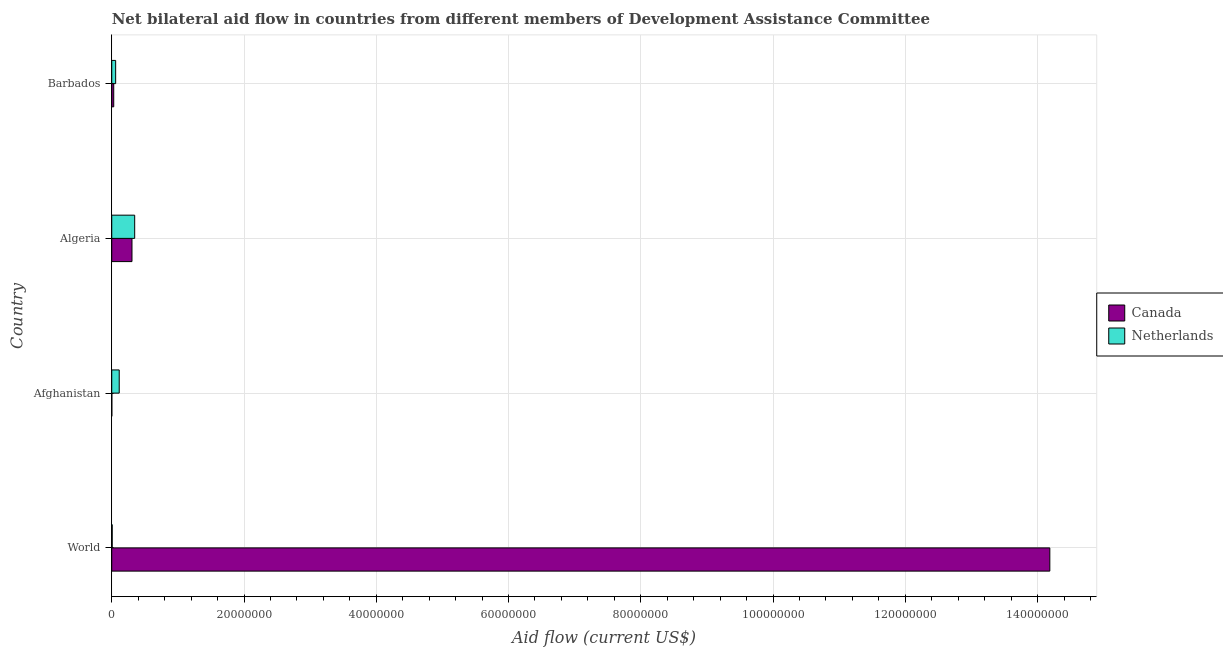How many different coloured bars are there?
Give a very brief answer. 2. Are the number of bars on each tick of the Y-axis equal?
Your answer should be very brief. Yes. How many bars are there on the 4th tick from the bottom?
Provide a short and direct response. 2. What is the label of the 1st group of bars from the top?
Keep it short and to the point. Barbados. What is the amount of aid given by netherlands in Afghanistan?
Your answer should be very brief. 1.13e+06. Across all countries, what is the maximum amount of aid given by canada?
Make the answer very short. 1.42e+08. Across all countries, what is the minimum amount of aid given by canada?
Your response must be concise. 10000. In which country was the amount of aid given by netherlands minimum?
Give a very brief answer. World. What is the total amount of aid given by netherlands in the graph?
Keep it short and to the point. 5.26e+06. What is the difference between the amount of aid given by netherlands in Afghanistan and that in World?
Make the answer very short. 1.06e+06. What is the difference between the amount of aid given by canada in Barbados and the amount of aid given by netherlands in Algeria?
Offer a terse response. -3.17e+06. What is the average amount of aid given by netherlands per country?
Ensure brevity in your answer.  1.32e+06. What is the difference between the amount of aid given by canada and amount of aid given by netherlands in Barbados?
Your answer should be very brief. -2.90e+05. In how many countries, is the amount of aid given by canada greater than 128000000 US$?
Ensure brevity in your answer.  1. What is the ratio of the amount of aid given by netherlands in Barbados to that in World?
Offer a terse response. 8.43. What is the difference between the highest and the second highest amount of aid given by netherlands?
Ensure brevity in your answer.  2.34e+06. What is the difference between the highest and the lowest amount of aid given by canada?
Offer a terse response. 1.42e+08. In how many countries, is the amount of aid given by netherlands greater than the average amount of aid given by netherlands taken over all countries?
Provide a succinct answer. 1. What does the 2nd bar from the top in Afghanistan represents?
Make the answer very short. Canada. How many bars are there?
Keep it short and to the point. 8. Where does the legend appear in the graph?
Make the answer very short. Center right. How many legend labels are there?
Make the answer very short. 2. How are the legend labels stacked?
Ensure brevity in your answer.  Vertical. What is the title of the graph?
Keep it short and to the point. Net bilateral aid flow in countries from different members of Development Assistance Committee. Does "DAC donors" appear as one of the legend labels in the graph?
Your response must be concise. No. What is the label or title of the X-axis?
Provide a succinct answer. Aid flow (current US$). What is the label or title of the Y-axis?
Make the answer very short. Country. What is the Aid flow (current US$) of Canada in World?
Offer a terse response. 1.42e+08. What is the Aid flow (current US$) in Netherlands in World?
Give a very brief answer. 7.00e+04. What is the Aid flow (current US$) of Netherlands in Afghanistan?
Provide a short and direct response. 1.13e+06. What is the Aid flow (current US$) in Canada in Algeria?
Provide a succinct answer. 3.06e+06. What is the Aid flow (current US$) of Netherlands in Algeria?
Provide a succinct answer. 3.47e+06. What is the Aid flow (current US$) of Netherlands in Barbados?
Your answer should be very brief. 5.90e+05. Across all countries, what is the maximum Aid flow (current US$) of Canada?
Provide a short and direct response. 1.42e+08. Across all countries, what is the maximum Aid flow (current US$) of Netherlands?
Offer a very short reply. 3.47e+06. What is the total Aid flow (current US$) in Canada in the graph?
Make the answer very short. 1.45e+08. What is the total Aid flow (current US$) in Netherlands in the graph?
Your answer should be very brief. 5.26e+06. What is the difference between the Aid flow (current US$) in Canada in World and that in Afghanistan?
Your answer should be compact. 1.42e+08. What is the difference between the Aid flow (current US$) in Netherlands in World and that in Afghanistan?
Ensure brevity in your answer.  -1.06e+06. What is the difference between the Aid flow (current US$) of Canada in World and that in Algeria?
Give a very brief answer. 1.39e+08. What is the difference between the Aid flow (current US$) of Netherlands in World and that in Algeria?
Offer a very short reply. -3.40e+06. What is the difference between the Aid flow (current US$) of Canada in World and that in Barbados?
Keep it short and to the point. 1.42e+08. What is the difference between the Aid flow (current US$) in Netherlands in World and that in Barbados?
Offer a very short reply. -5.20e+05. What is the difference between the Aid flow (current US$) in Canada in Afghanistan and that in Algeria?
Make the answer very short. -3.05e+06. What is the difference between the Aid flow (current US$) in Netherlands in Afghanistan and that in Algeria?
Your response must be concise. -2.34e+06. What is the difference between the Aid flow (current US$) in Netherlands in Afghanistan and that in Barbados?
Provide a short and direct response. 5.40e+05. What is the difference between the Aid flow (current US$) of Canada in Algeria and that in Barbados?
Make the answer very short. 2.76e+06. What is the difference between the Aid flow (current US$) of Netherlands in Algeria and that in Barbados?
Provide a succinct answer. 2.88e+06. What is the difference between the Aid flow (current US$) of Canada in World and the Aid flow (current US$) of Netherlands in Afghanistan?
Give a very brief answer. 1.41e+08. What is the difference between the Aid flow (current US$) in Canada in World and the Aid flow (current US$) in Netherlands in Algeria?
Give a very brief answer. 1.38e+08. What is the difference between the Aid flow (current US$) of Canada in World and the Aid flow (current US$) of Netherlands in Barbados?
Give a very brief answer. 1.41e+08. What is the difference between the Aid flow (current US$) in Canada in Afghanistan and the Aid flow (current US$) in Netherlands in Algeria?
Give a very brief answer. -3.46e+06. What is the difference between the Aid flow (current US$) in Canada in Afghanistan and the Aid flow (current US$) in Netherlands in Barbados?
Ensure brevity in your answer.  -5.80e+05. What is the difference between the Aid flow (current US$) in Canada in Algeria and the Aid flow (current US$) in Netherlands in Barbados?
Provide a short and direct response. 2.47e+06. What is the average Aid flow (current US$) of Canada per country?
Give a very brief answer. 3.63e+07. What is the average Aid flow (current US$) of Netherlands per country?
Your answer should be compact. 1.32e+06. What is the difference between the Aid flow (current US$) of Canada and Aid flow (current US$) of Netherlands in World?
Keep it short and to the point. 1.42e+08. What is the difference between the Aid flow (current US$) in Canada and Aid flow (current US$) in Netherlands in Afghanistan?
Your answer should be compact. -1.12e+06. What is the difference between the Aid flow (current US$) in Canada and Aid flow (current US$) in Netherlands in Algeria?
Provide a short and direct response. -4.10e+05. What is the ratio of the Aid flow (current US$) in Canada in World to that in Afghanistan?
Ensure brevity in your answer.  1.42e+04. What is the ratio of the Aid flow (current US$) in Netherlands in World to that in Afghanistan?
Provide a short and direct response. 0.06. What is the ratio of the Aid flow (current US$) in Canada in World to that in Algeria?
Offer a very short reply. 46.36. What is the ratio of the Aid flow (current US$) in Netherlands in World to that in Algeria?
Your answer should be very brief. 0.02. What is the ratio of the Aid flow (current US$) of Canada in World to that in Barbados?
Give a very brief answer. 472.83. What is the ratio of the Aid flow (current US$) in Netherlands in World to that in Barbados?
Keep it short and to the point. 0.12. What is the ratio of the Aid flow (current US$) of Canada in Afghanistan to that in Algeria?
Make the answer very short. 0. What is the ratio of the Aid flow (current US$) of Netherlands in Afghanistan to that in Algeria?
Provide a succinct answer. 0.33. What is the ratio of the Aid flow (current US$) in Canada in Afghanistan to that in Barbados?
Your answer should be compact. 0.03. What is the ratio of the Aid flow (current US$) of Netherlands in Afghanistan to that in Barbados?
Your answer should be very brief. 1.92. What is the ratio of the Aid flow (current US$) in Netherlands in Algeria to that in Barbados?
Your response must be concise. 5.88. What is the difference between the highest and the second highest Aid flow (current US$) of Canada?
Provide a short and direct response. 1.39e+08. What is the difference between the highest and the second highest Aid flow (current US$) of Netherlands?
Your answer should be very brief. 2.34e+06. What is the difference between the highest and the lowest Aid flow (current US$) of Canada?
Your answer should be compact. 1.42e+08. What is the difference between the highest and the lowest Aid flow (current US$) in Netherlands?
Make the answer very short. 3.40e+06. 